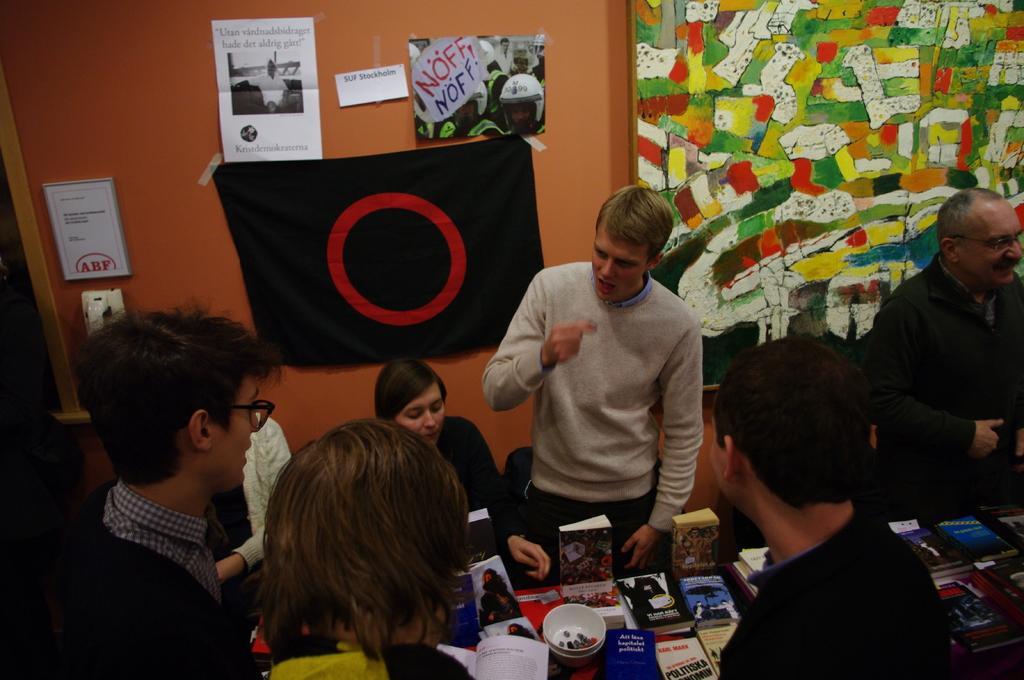Can you describe this image briefly? In this image we can see two people sitting and the rest are standing in front of the table and on the table we can see many different books. In the background there is a painting board, papers with text and also images and we can also see a black color cloth with red color ring and these papers, frame and cloth are attached to the plain wall. 